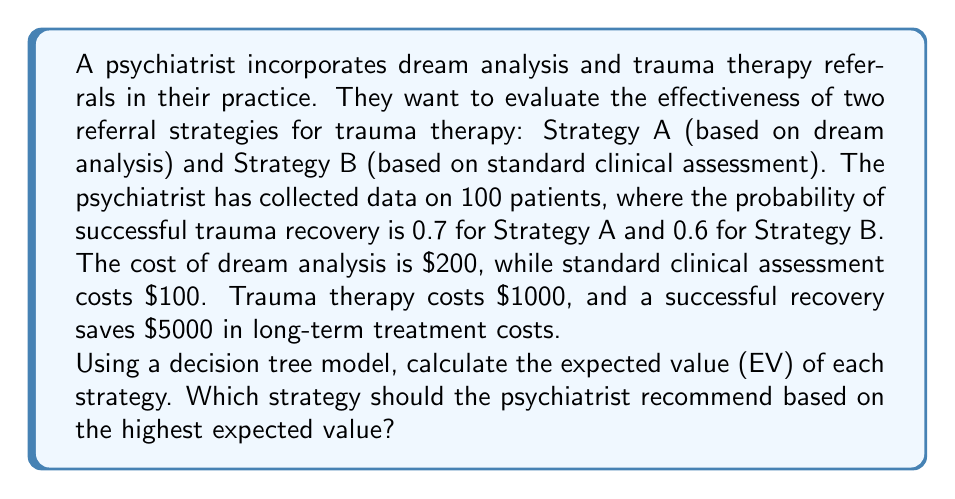Solve this math problem. Let's build a decision tree model and calculate the expected value for each strategy:

1. Strategy A (Dream Analysis):
   - Cost of dream analysis: $200
   - Probability of successful recovery: 0.7
   - Probability of unsuccessful recovery: 0.3
   
   EV(A) = -200 - 1000 + 0.7(5000) + 0.3(0)
   
   $$EV(A) = -1200 + 3500 = $2300$$

2. Strategy B (Standard Clinical Assessment):
   - Cost of standard assessment: $100
   - Probability of successful recovery: 0.6
   - Probability of unsuccessful recovery: 0.4
   
   EV(B) = -100 - 1000 + 0.6(5000) + 0.4(0)
   
   $$EV(B) = -1100 + 3000 = $1900$$

To determine which strategy to recommend, we compare the expected values:

$$EV(A) > EV(B)$$
$$2300 > 1900$$

Therefore, Strategy A (Dream Analysis) has a higher expected value and should be recommended.
Answer: Strategy A (Dream Analysis), EV = $2300 